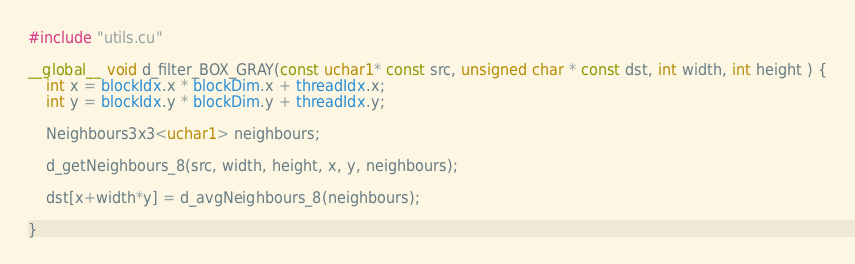<code> <loc_0><loc_0><loc_500><loc_500><_Cuda_>#include "utils.cu"

__global__ void d_filter_BOX_GRAY(const uchar1* const src, unsigned char * const dst, int width, int height ) {
	int x = blockIdx.x * blockDim.x + threadIdx.x;
	int y = blockIdx.y * blockDim.y + threadIdx.y;
	
	Neighbours3x3<uchar1> neighbours;
	
	d_getNeighbours_8(src, width, height, x, y, neighbours);
	
	dst[x+width*y] = d_avgNeighbours_8(neighbours);

}

</code> 